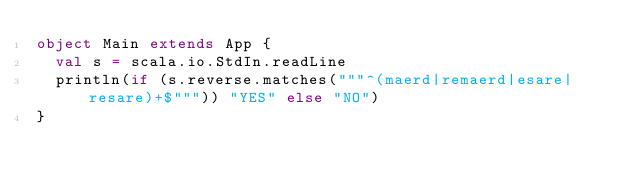<code> <loc_0><loc_0><loc_500><loc_500><_Scala_>object Main extends App {
  val s = scala.io.StdIn.readLine
  println(if (s.reverse.matches("""^(maerd|remaerd|esare|resare)+$""")) "YES" else "NO")
}</code> 